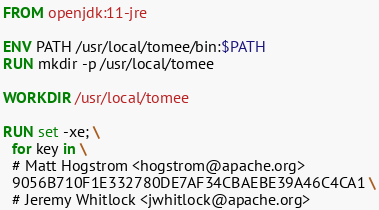<code> <loc_0><loc_0><loc_500><loc_500><_Dockerfile_>FROM openjdk:11-jre

ENV PATH /usr/local/tomee/bin:$PATH
RUN mkdir -p /usr/local/tomee

WORKDIR /usr/local/tomee

RUN set -xe; \
  for key in \
  # Matt Hogstrom <hogstrom@apache.org>
  9056B710F1E332780DE7AF34CBAEBE39A46C4CA1 \
  # Jeremy Whitlock <jwhitlock@apache.org></code> 